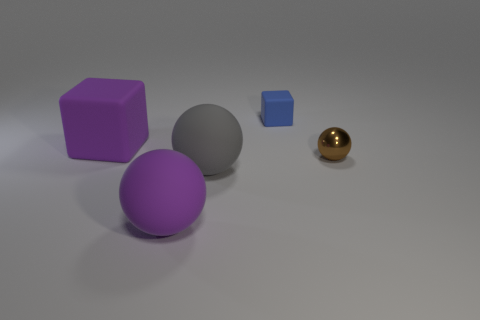How many other objects are the same material as the tiny blue thing?
Make the answer very short. 3. What is the color of the big cube that is the same material as the tiny blue cube?
Your response must be concise. Purple. There is a gray matte sphere right of the purple matte ball; is it the same size as the blue rubber object?
Your answer should be compact. No. What number of objects are either big gray matte balls or green blocks?
Make the answer very short. 1. What is the material of the block that is to the left of the cube that is behind the large purple matte object that is behind the big gray object?
Your answer should be compact. Rubber. There is a large purple object behind the tiny metal object; what is its material?
Your answer should be very brief. Rubber. Are there any shiny spheres that have the same size as the shiny thing?
Give a very brief answer. No. Does the small object behind the purple rubber block have the same color as the tiny metallic thing?
Make the answer very short. No. How many blue objects are rubber blocks or big objects?
Keep it short and to the point. 1. What number of balls are the same color as the big cube?
Your answer should be very brief. 1. 